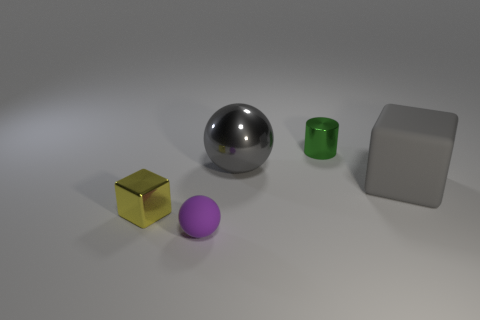Do the large shiny sphere and the big rubber object have the same color?
Keep it short and to the point. Yes. Is there a brown ball of the same size as the shiny block?
Give a very brief answer. No. The yellow shiny object that is the same size as the green thing is what shape?
Offer a terse response. Cube. What number of other objects are the same color as the big shiny thing?
Make the answer very short. 1. There is a object that is in front of the gray shiny thing and behind the small yellow metal object; what shape is it?
Provide a short and direct response. Cube. There is a tiny metal object on the right side of the shiny thing that is on the left side of the purple object; is there a rubber thing left of it?
Offer a very short reply. Yes. How many other things are there of the same material as the big block?
Make the answer very short. 1. How many large cylinders are there?
Keep it short and to the point. 0. How many objects are either yellow objects or small things to the right of the small shiny cube?
Ensure brevity in your answer.  3. Is there anything else that has the same shape as the green object?
Keep it short and to the point. No. 